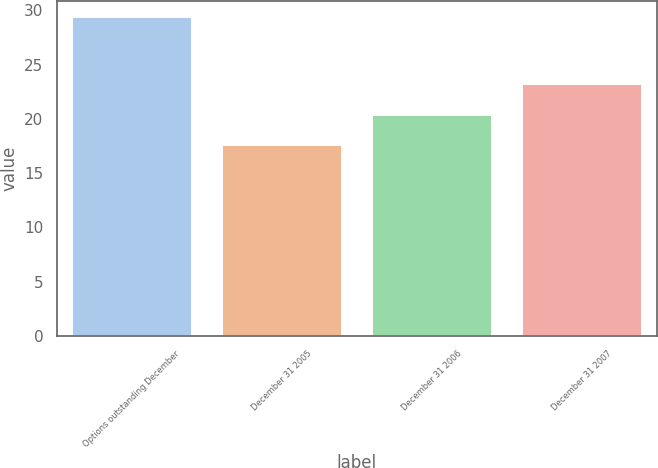<chart> <loc_0><loc_0><loc_500><loc_500><bar_chart><fcel>Options outstanding December<fcel>December 31 2005<fcel>December 31 2006<fcel>December 31 2007<nl><fcel>29.39<fcel>17.63<fcel>20.37<fcel>23.24<nl></chart> 